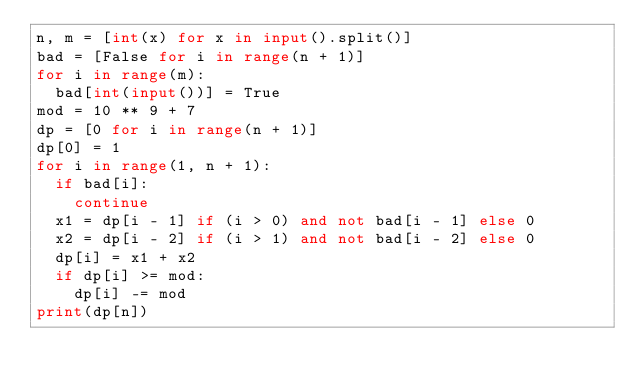Convert code to text. <code><loc_0><loc_0><loc_500><loc_500><_Python_>n, m = [int(x) for x in input().split()]
bad = [False for i in range(n + 1)]
for i in range(m):
  bad[int(input())] = True
mod = 10 ** 9 + 7
dp = [0 for i in range(n + 1)]
dp[0] = 1
for i in range(1, n + 1):
  if bad[i]: 
    continue
  x1 = dp[i - 1] if (i > 0) and not bad[i - 1] else 0
  x2 = dp[i - 2] if (i > 1) and not bad[i - 2] else 0
  dp[i] = x1 + x2
  if dp[i] >= mod:
    dp[i] -= mod
print(dp[n])</code> 